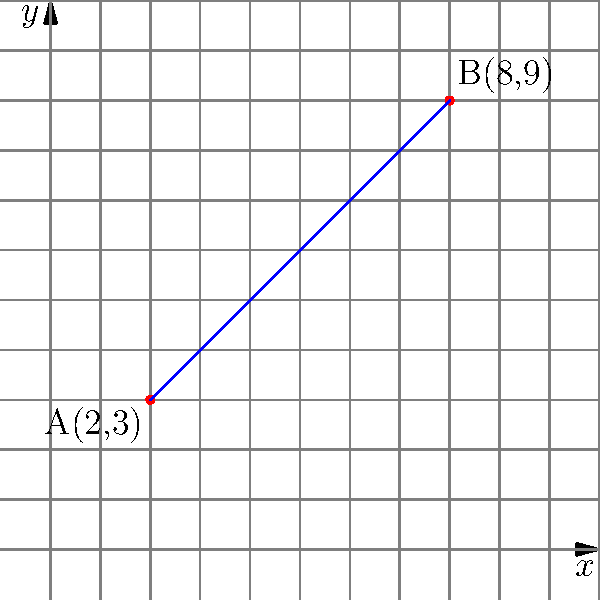As a trail steward, you need to measure the distance between two trail markers for maintenance purposes. Marker A is located at coordinates (2,3) and marker B is at (8,9) on your trail map. Using the distance formula, calculate the distance between these two markers to the nearest tenth of a unit. To find the distance between two points, we use the distance formula:

$$ d = \sqrt{(x_2-x_1)^2 + (y_2-y_1)^2} $$

Where $(x_1,y_1)$ are the coordinates of the first point and $(x_2,y_2)$ are the coordinates of the second point.

Step 1: Identify the coordinates
Point A: $(x_1,y_1) = (2,3)$
Point B: $(x_2,y_2) = (8,9)$

Step 2: Plug the coordinates into the distance formula
$$ d = \sqrt{(8-2)^2 + (9-3)^2} $$

Step 3: Simplify the expressions inside the parentheses
$$ d = \sqrt{6^2 + 6^2} $$

Step 4: Calculate the squares
$$ d = \sqrt{36 + 36} $$

Step 5: Add the terms under the square root
$$ d = \sqrt{72} $$

Step 6: Simplify the square root
$$ d = 6\sqrt{2} \approx 8.485 $$

Step 7: Round to the nearest tenth
$$ d \approx 8.5 $$

Therefore, the distance between the two trail markers is approximately 8.5 units.
Answer: 8.5 units 